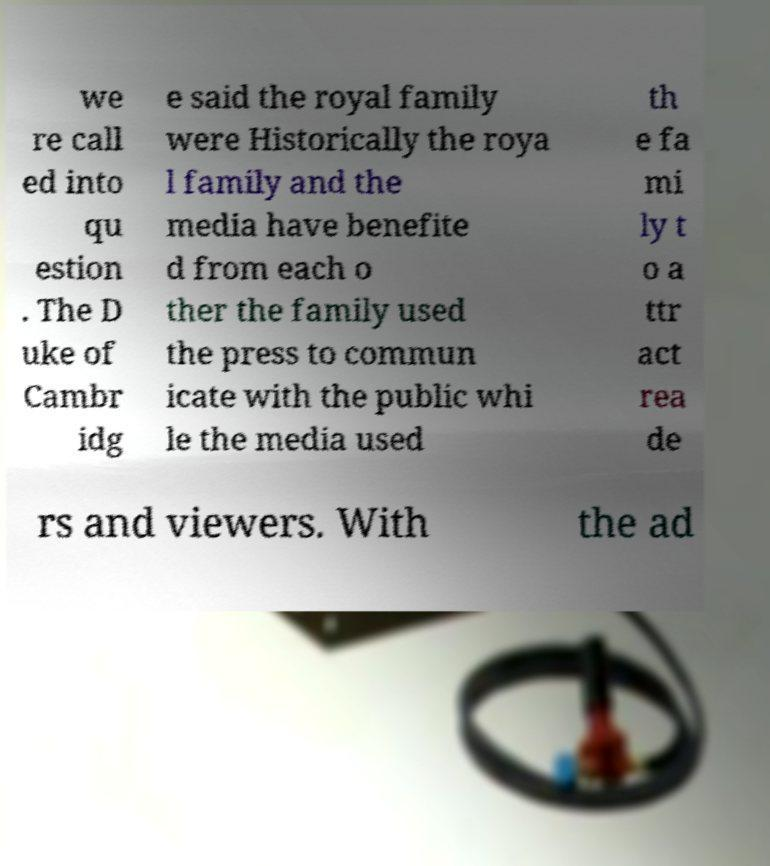Can you accurately transcribe the text from the provided image for me? we re call ed into qu estion . The D uke of Cambr idg e said the royal family were Historically the roya l family and the media have benefite d from each o ther the family used the press to commun icate with the public whi le the media used th e fa mi ly t o a ttr act rea de rs and viewers. With the ad 